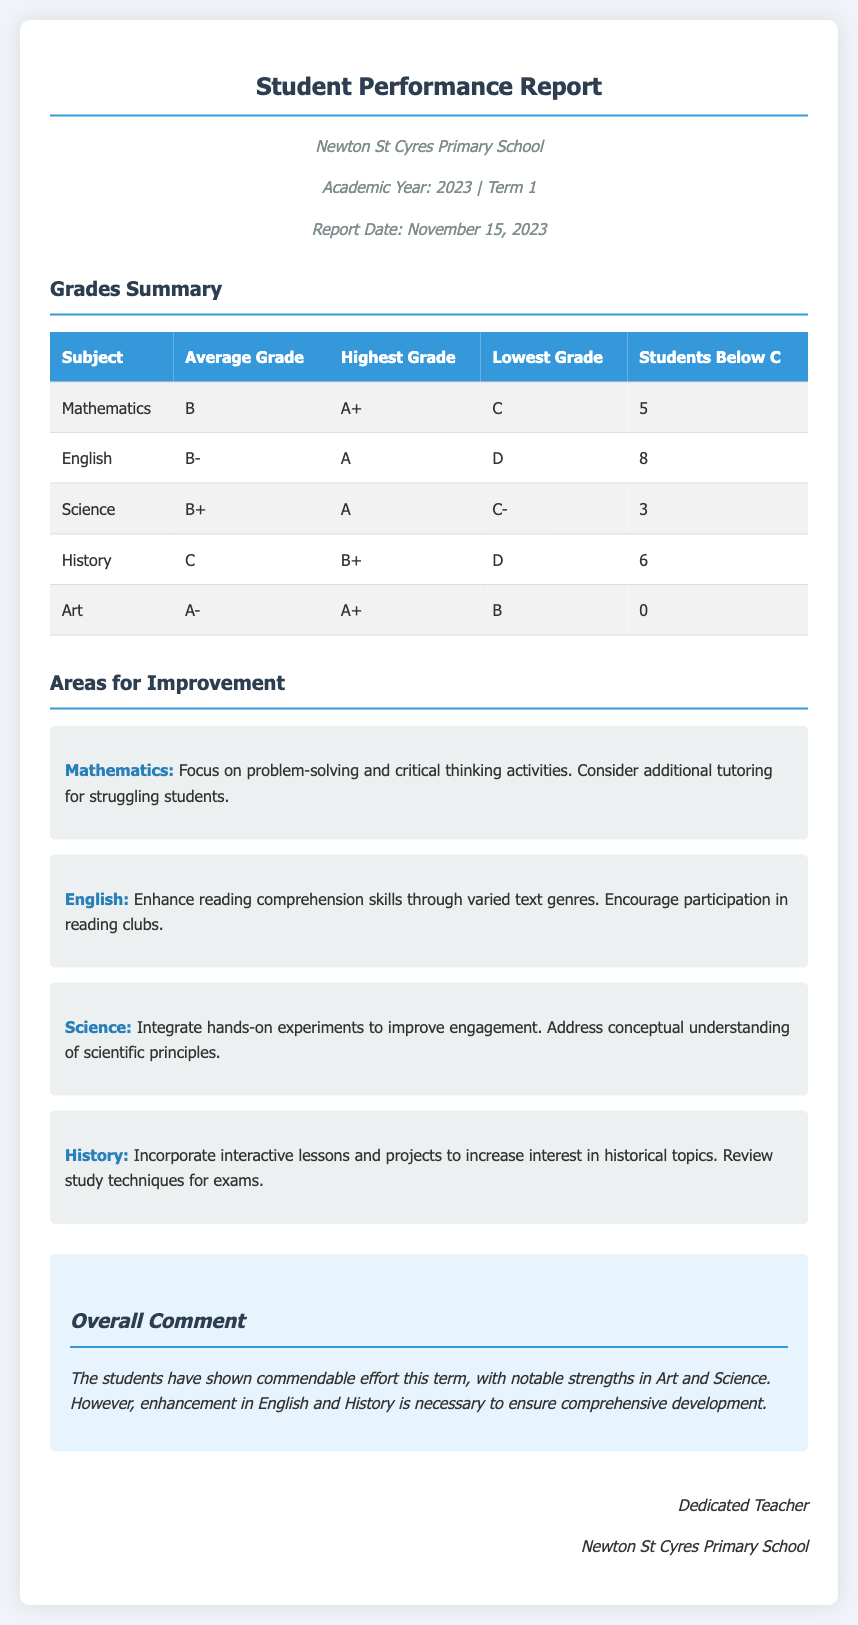What is the average grade in Mathematics? The average grade in Mathematics is highlighted in the table under the "Average Grade" column.
Answer: B How many students scored below a C in English? The number of students below a C in English is provided in the "Students Below C" column of the grades summary.
Answer: 8 What is the highest grade achieved in Science? The highest grade in Science is listed in the table under the "Highest Grade" column.
Answer: A Which subject had no students below a C? The subjects with zero students below a C can be directly identified from the "Students Below C" column in the grades summary.
Answer: Art What improvement is suggested for History? The areas for improvement for each subject are detailed at the end of each subject section.
Answer: Incorporate interactive lessons and projects What is the overall comment about student performance? The overall comment summarizes the performance strengths and weaknesses based on the information in the report.
Answer: The students have shown commendable effort this term, with notable strengths in Art and Science What is the report date? The report date is stated at the top of the document, allowing easy identification.
Answer: November 15, 2023 What is the lowest grade received in History? The lowest grade in History can be found in the "Lowest Grade" column of the grades summary table.
Answer: D How many students scored below a C in Mathematics? The number mentioned in the "Students Below C" column for Mathematics indicates the relevant data.
Answer: 5 